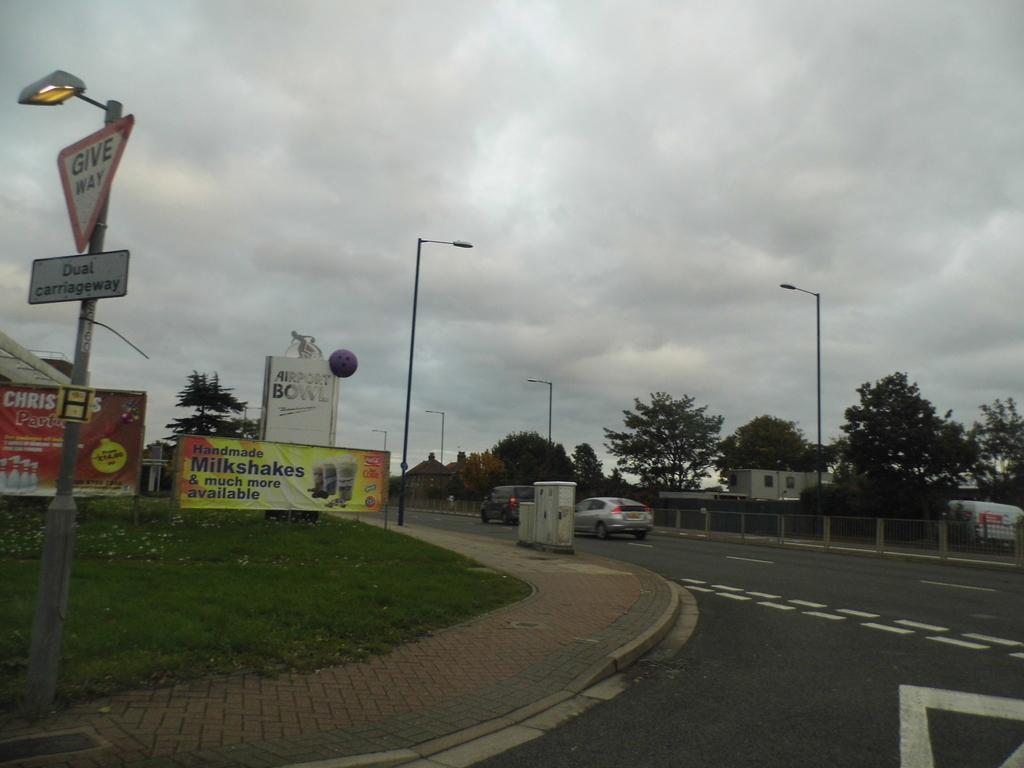Please provide a concise description of this image. In this image there is grass on the ground and there are poles and cars moving on the road. There are trees and there are banners with some text written on it and the sky is cloudy. 